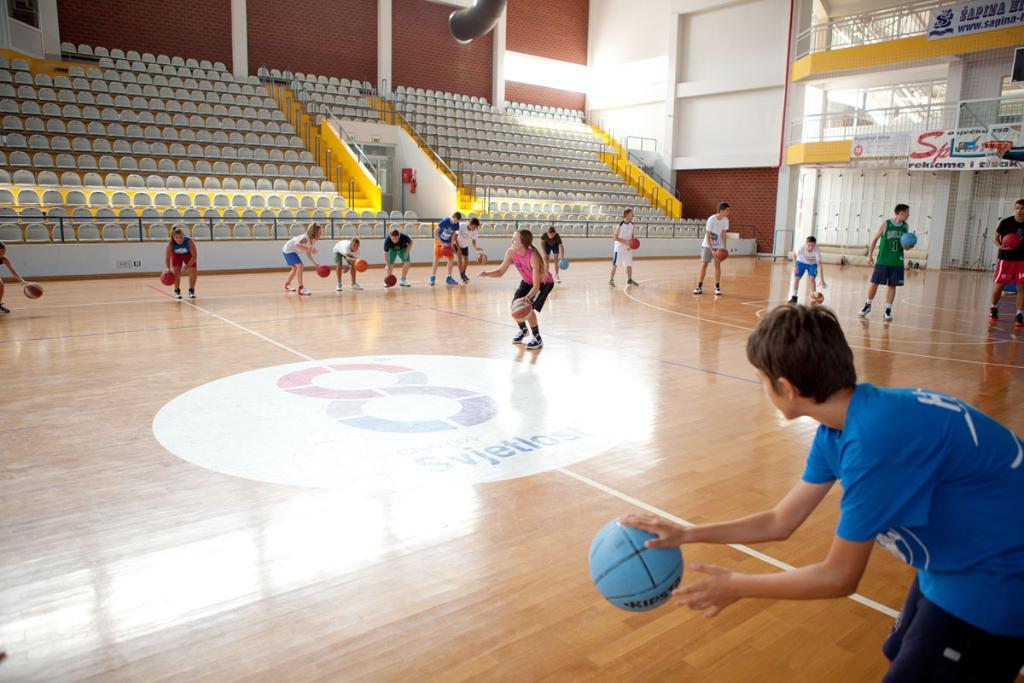<image>
Write a terse but informative summary of the picture. kids in a big inside gym bounce basketballs on a court with a number 8 on it 